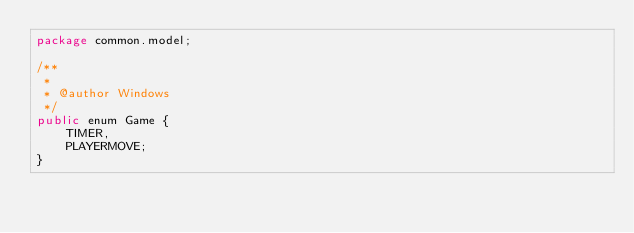Convert code to text. <code><loc_0><loc_0><loc_500><loc_500><_Java_>package common.model;

/**
 *
 * @author Windows
 */
public enum Game {
    TIMER,
    PLAYERMOVE;
}
</code> 